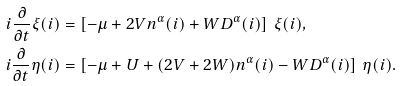<formula> <loc_0><loc_0><loc_500><loc_500>i \frac { \partial } { \partial t } \xi ( i ) & = \left [ - \mu + 2 V n ^ { \alpha } ( i ) + W D ^ { \alpha } ( i ) \right ] \, \xi ( i ) , \\ i \frac { \partial } { \partial t } \eta ( i ) & = \left [ - \mu + U + ( 2 V + 2 W ) n ^ { \alpha } ( i ) - W D ^ { \alpha } ( i ) \right ] \, \eta ( i ) .</formula> 